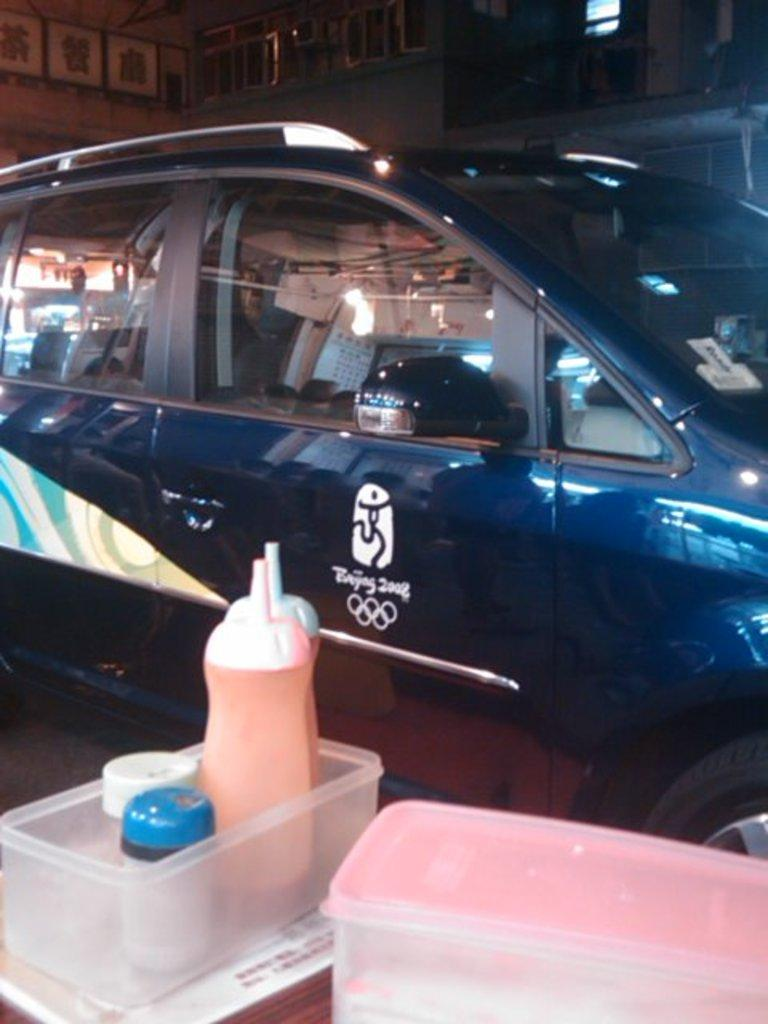What is the main subject in the center of the image? There is a car in the center of the image. What is located at the bottom of the image? There is a table at the bottom of the image. What items can be seen on the table? There are boxes and bottles on the table. What can be seen in the distance in the image? There are buildings in the background of the image. What is the weight of the things that are not present in the image? There are no specific "things" mentioned in the image, so it's not possible to determine their weight. 